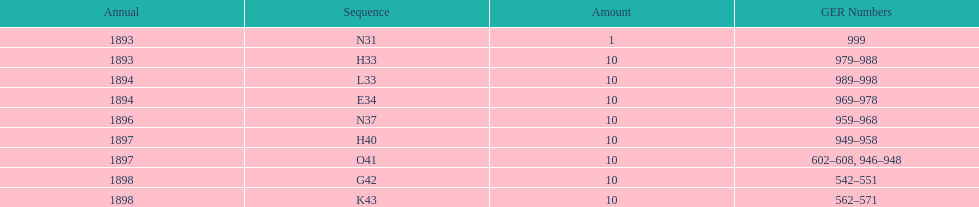Were there more n31 or e34 ordered? E34. 